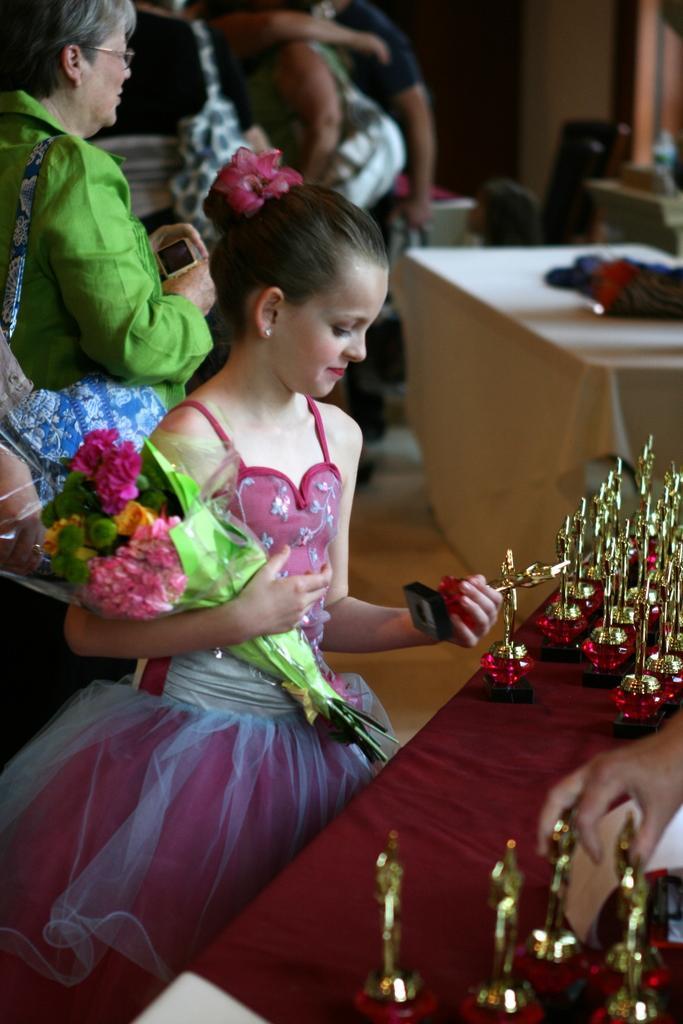In one or two sentences, can you explain what this image depicts? In this image we can see a child wearing frock is holding a flower bouquet. Here we can see some objects are placed on the table. The background of the image is slightly blurred, where we can see a few people on the floor and a table here. 